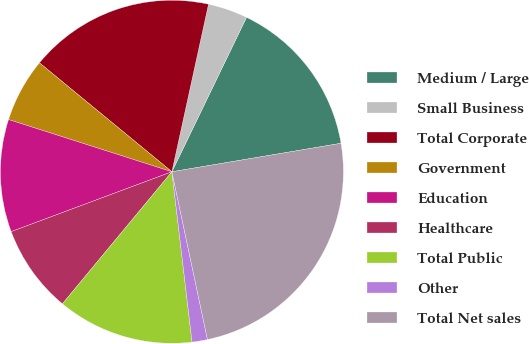<chart> <loc_0><loc_0><loc_500><loc_500><pie_chart><fcel>Medium / Large<fcel>Small Business<fcel>Total Corporate<fcel>Government<fcel>Education<fcel>Healthcare<fcel>Total Public<fcel>Other<fcel>Total Net sales<nl><fcel>15.18%<fcel>3.74%<fcel>17.47%<fcel>6.03%<fcel>10.6%<fcel>8.31%<fcel>12.89%<fcel>1.45%<fcel>24.33%<nl></chart> 